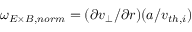<formula> <loc_0><loc_0><loc_500><loc_500>\omega _ { E \times B , n o r m } = ( \partial v _ { \perp } / \partial r ) ( a / v _ { t h , i } )</formula> 